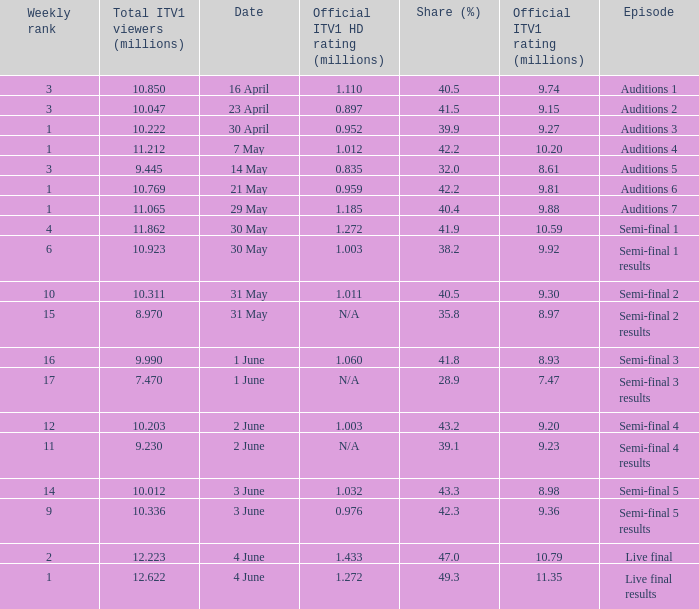What was the official ITV1 HD rating in millions for the episode that had an official ITV1 rating of 8.98 million? 1.032. 